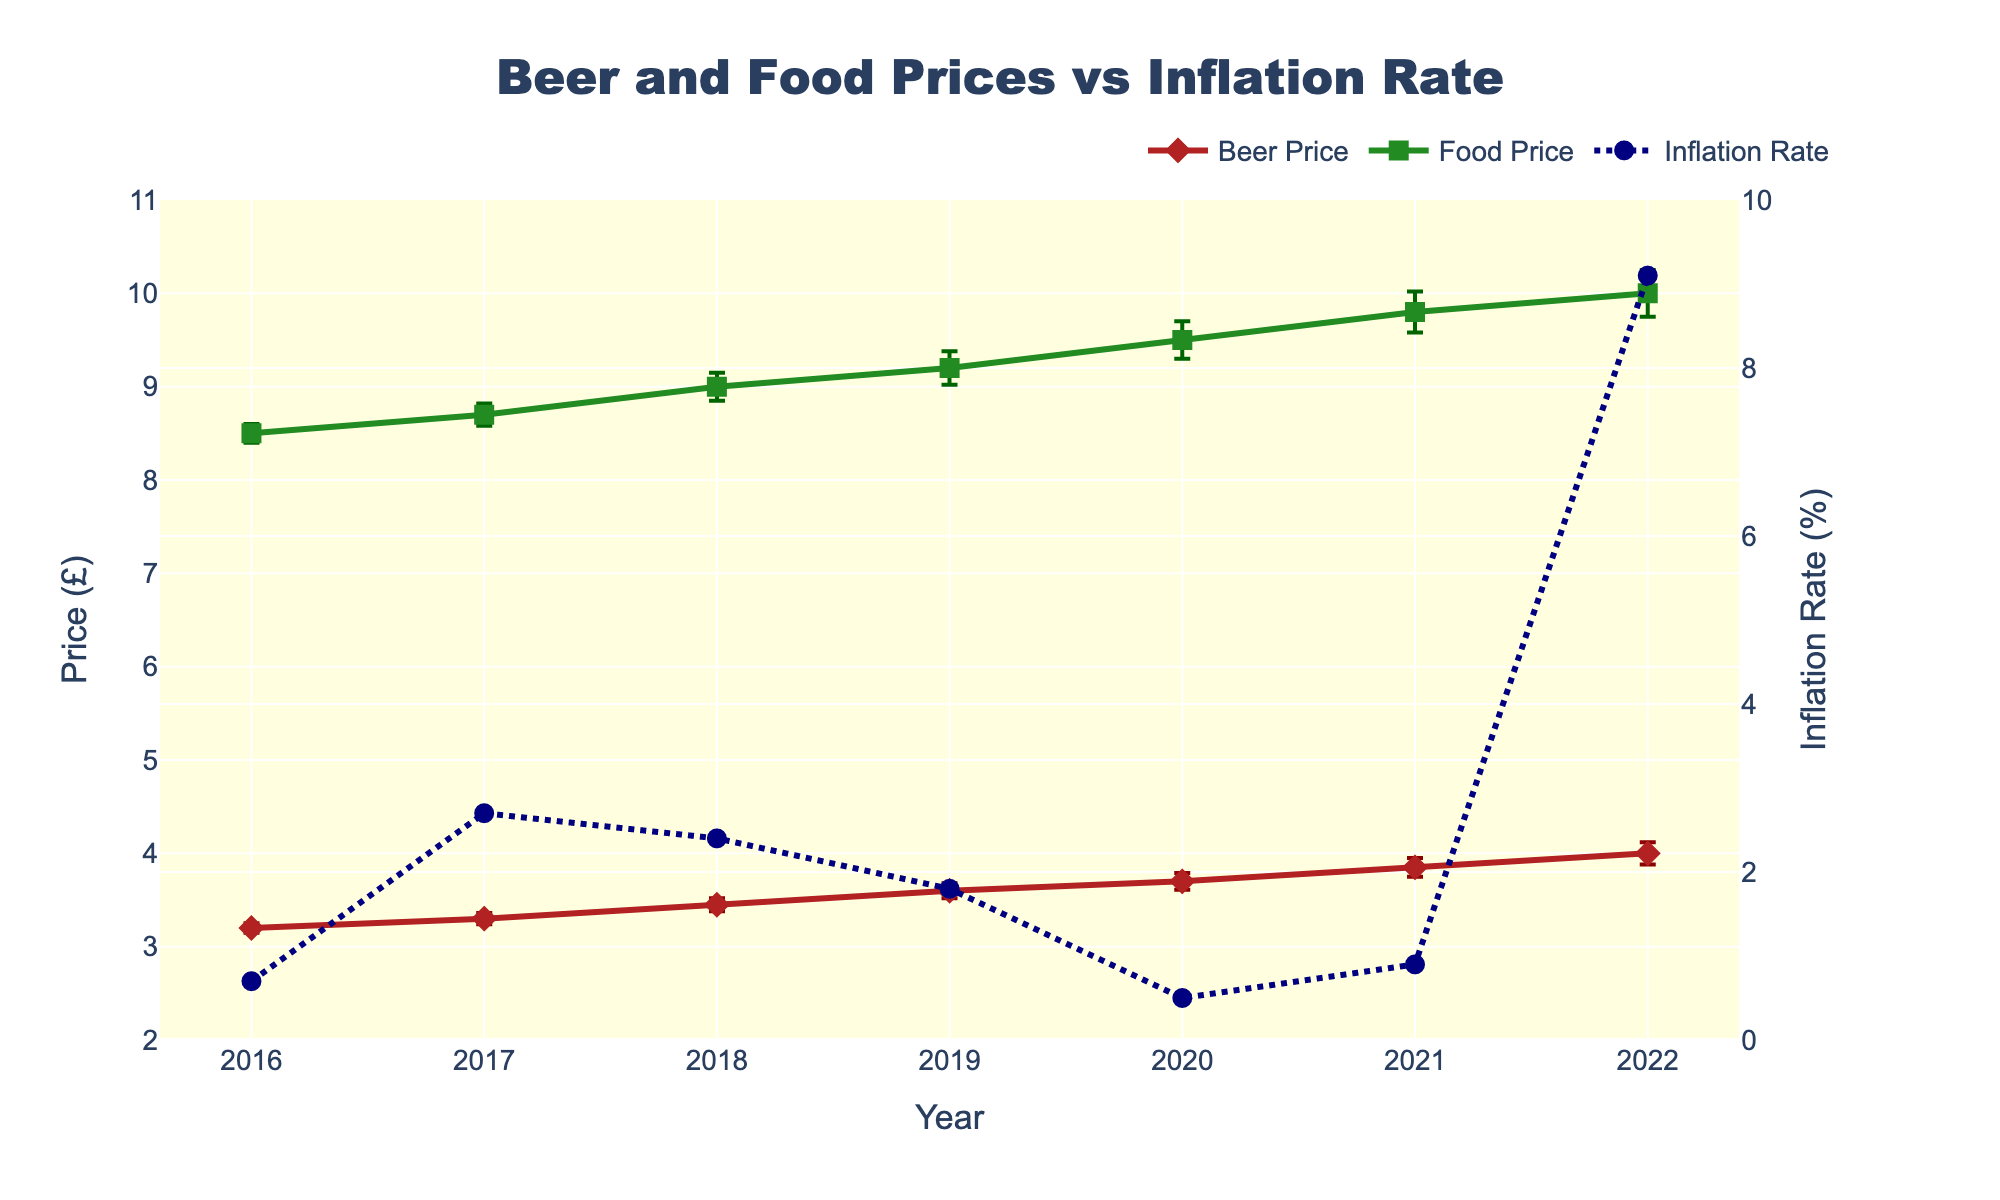How many years are shown in the figure? There are data points for each year from 2016 to 2022. Counting all the years inclusive gives us seven years.
Answer: Seven What are the colors used to represent beer prices, food prices, and inflation rates? The beer prices are represented in firebrick color, the food prices in forest green, and the inflation rates in navy blue.
Answer: Firebrick, forest green, navy blue Which year had the highest inflation rate? By observing the line representing the inflation rate, we see that the highest point occurs in the year 2022.
Answer: 2022 What's the difference in beer prices between the years 2016 and 2022? The beer price in 2016 is £3.20, and in 2022 it is £4.00. The difference is calculated as £4.00 - £3.20.
Answer: £0.80 What are the error values for beer and food prices in the year 2019? Observing the error bars for both beer and food prices in 2019, the error value for beer is £0.08 and for food, it is £0.18.
Answer: £0.08 for beer, £0.18 for food Which had a greater overall increase from 2016 to 2022, beer prices or food prices? Beer prices increased from £3.20 to £4.00, a £0.80 increase. Food prices increased from £8.50 to £10.00, a £1.50 increase.
Answer: Food prices How did the inflation rate compare between 2020 and 2021? The inflation rate in 2020 was 0.5%, and in 2021 it was 0.9%. The rate increased by 0.4% from 2020 to 2021.
Answer: Increased by 0.4% What is the relationship between inflation rates and food prices from 2016 to 2022? Overall, both food prices and inflation rates generally rose over the period, though food prices increased steadily while inflation rates fluctuated more prominently.
Answer: Both rose What is the range of the food prices shown in the figure? The lowest food price shown is £8.50 in 2016, and the highest food price is £10.00 in 2022. Hence, the range is £10.00 - £8.50.
Answer: £1.50 Did any year have a difference in beer price error bars greater than 0.02 from the previous year? From 2016 to 2017, the difference in beer price errors is 0.06 - 0.05 = 0.01. From 2017 to 2018, it's 0.07 - 0.06 = 0.01. From 2018 to 2019, it's 0.08 - 0.07 = 0.01. From 2019 to 2020, it's 0.09 - 0.08 = 0.01. From 2020 to 2021, it's 0.10 - 0.09 = 0.01. From 2021 to 2022, it's 0.12 - 0.10 = 0.02. No differences greater than 0.02.
Answer: No 